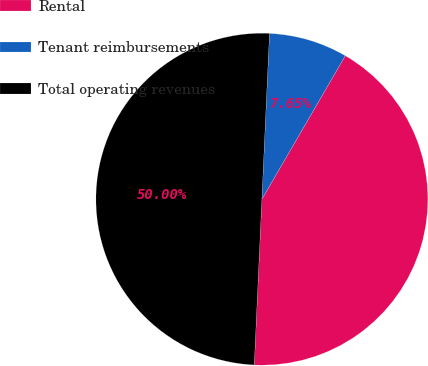Convert chart. <chart><loc_0><loc_0><loc_500><loc_500><pie_chart><fcel>Rental<fcel>Tenant reimbursements<fcel>Total operating revenues<nl><fcel>42.35%<fcel>7.65%<fcel>50.0%<nl></chart> 